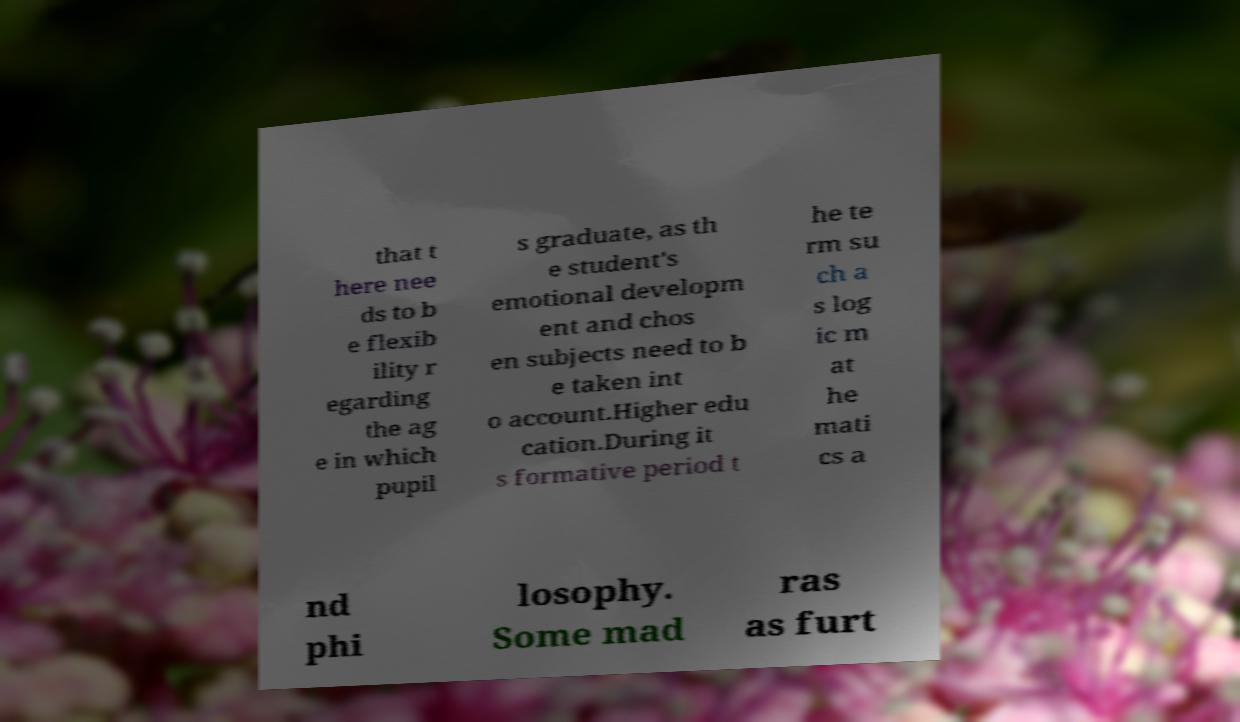Please read and relay the text visible in this image. What does it say? that t here nee ds to b e flexib ility r egarding the ag e in which pupil s graduate, as th e student's emotional developm ent and chos en subjects need to b e taken int o account.Higher edu cation.During it s formative period t he te rm su ch a s log ic m at he mati cs a nd phi losophy. Some mad ras as furt 